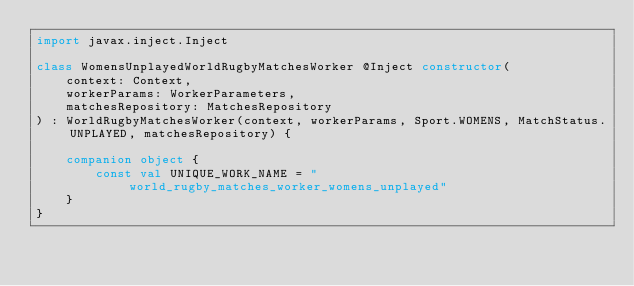Convert code to text. <code><loc_0><loc_0><loc_500><loc_500><_Kotlin_>import javax.inject.Inject

class WomensUnplayedWorldRugbyMatchesWorker @Inject constructor(
    context: Context,
    workerParams: WorkerParameters,
    matchesRepository: MatchesRepository
) : WorldRugbyMatchesWorker(context, workerParams, Sport.WOMENS, MatchStatus.UNPLAYED, matchesRepository) {

    companion object {
        const val UNIQUE_WORK_NAME = "world_rugby_matches_worker_womens_unplayed"
    }
}
</code> 